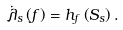<formula> <loc_0><loc_0><loc_500><loc_500>\dot { \lambda } _ { s } \left ( f \right ) = h _ { f } \left ( S _ { s } \right ) .</formula> 